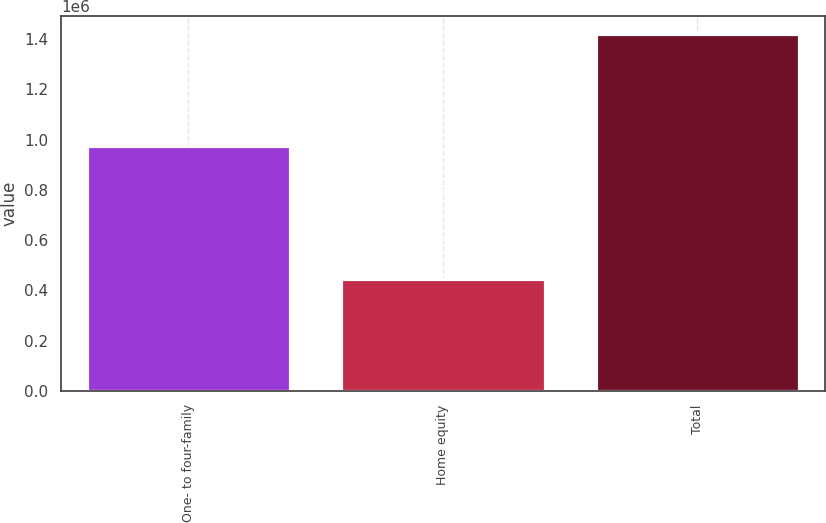<chart> <loc_0><loc_0><loc_500><loc_500><bar_chart><fcel>One- to four-family<fcel>Home equity<fcel>Total<nl><fcel>972953<fcel>445939<fcel>1.41889e+06<nl></chart> 